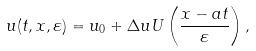<formula> <loc_0><loc_0><loc_500><loc_500>u ( t , x , \varepsilon ) = u _ { 0 } + \Delta u U \left ( \frac { x - a t } { \varepsilon } \right ) ,</formula> 